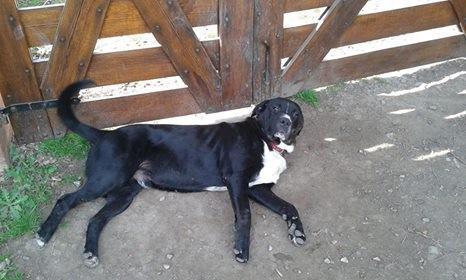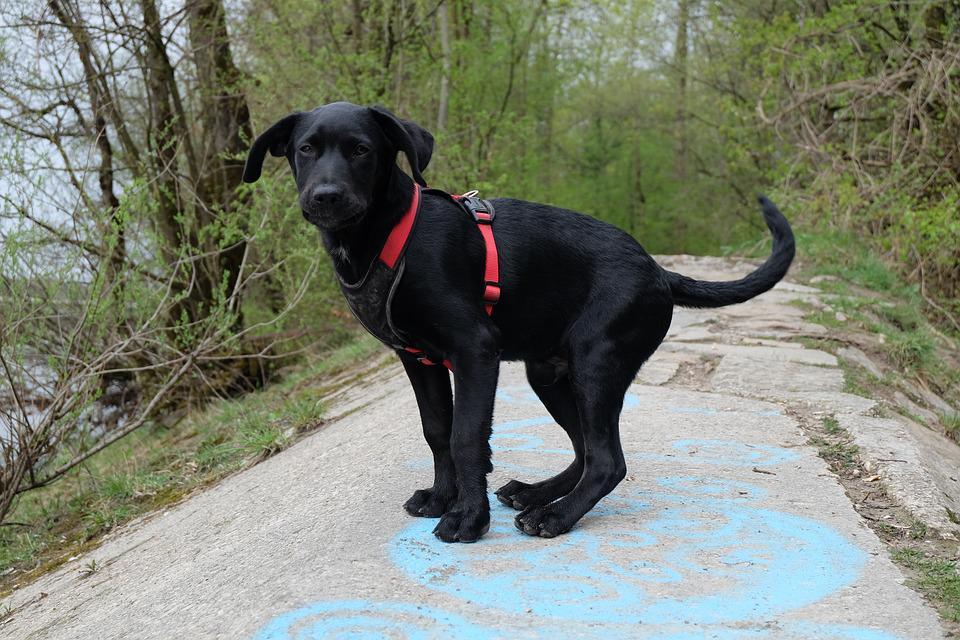The first image is the image on the left, the second image is the image on the right. Considering the images on both sides, is "There is at most 1 Yellow Labrador sitting besides 2 darker Labradors." valid? Answer yes or no. No. The first image is the image on the left, the second image is the image on the right. Considering the images on both sides, is "There is only one dog that is definitely in a sitting position." valid? Answer yes or no. No. 